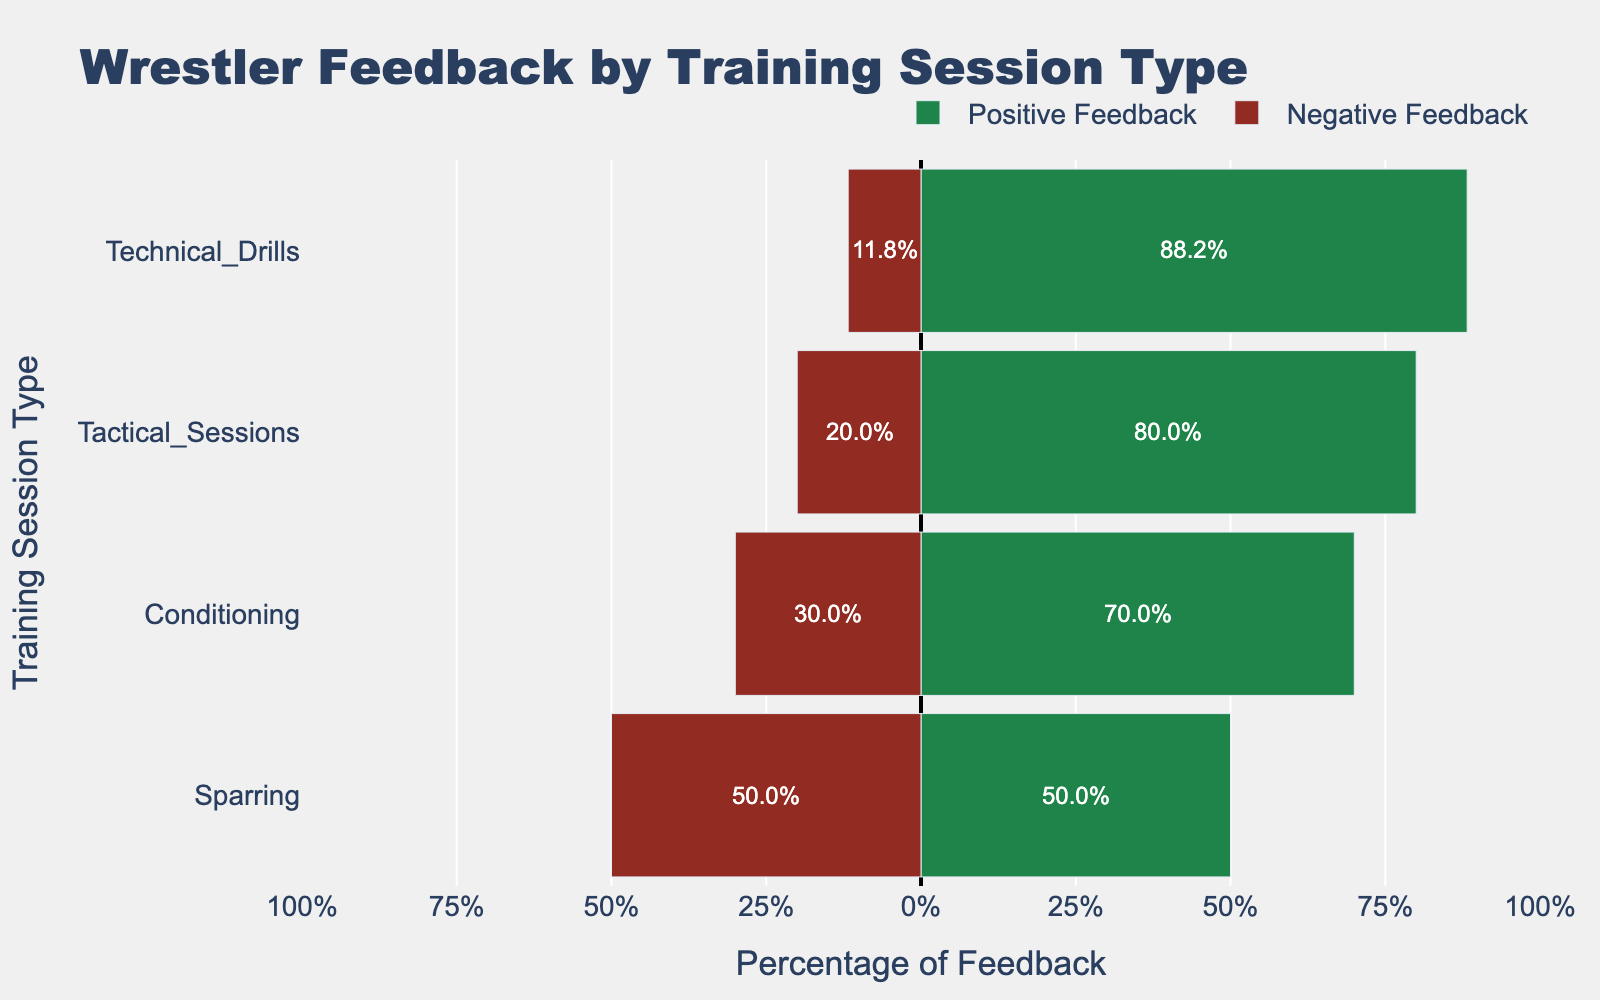Which training session type has the highest percentage of positive feedback? By looking at the chart, identify the training session type with the longest green bar (positive feedback percentage).
Answer: Technical Drills Which training session type has the highest percentage of negative feedback? By looking at the chart, identify the training session type with the longest red bar (negative feedback percentage).
Answer: Sparring What is the total feedback (positive and negative combined) percentage for Conditioning sessions? Sum the lengths of the green and red bars for Conditioning. Positive feedback percentage for Conditioning is around 72% and the negative feedback percentage is around -28%.
Answer: 100% Which training session type has the smallest difference between positive and negative feedback percentages? Compare the differences between the positive and negative percentages for each training session type by visual inspection. Sparring has nearly equal lengths for positive and negative feedback bars.
Answer: Sparring What is the average percentage of positive feedback across all training session types? Sum the positive feedback percentages for all training types and divide by the number of types. Positive percentages are roughly 71.4% (Conditioning), 85.3% (Technical Drills), 50% (Sparring), 82.1% (Tactical Sessions). The average is (71.4 + 85.3 + 50 + 82.1)/4 = 72.2%
Answer: 72.2% Which training session type has a greater negative feedback percentage than positive feedback percentage? Identify the training session type with a longer red bar than the green bar.
Answer: Sparring How much higher is the positive feedback percentage for Technical Drills compared to Conditioning? Subtract the positive feedback percentage of Conditioning from that of Technical Drills. Positive feedback for Technical Drills is 85.3%, for Conditioning is 71.4%. So, 85.3 - 71.4 = 13.9%
Answer: 13.9% What is the feedback ratio of positive to negative feedback for Tactical Sessions? Find the positive and negative feedback percentages for Tactical Sessions and divide the positive by the negative. Positive feedback is 82.1%, negative feedback is 17.9%. The ratio is 82.1 / 17.9 = 4.6
Answer: 4.6 Which training session type shows the most balanced feedback distribution? Look for training sessions where the green and red bars are closest to each other in length.
Answer: Sparring 